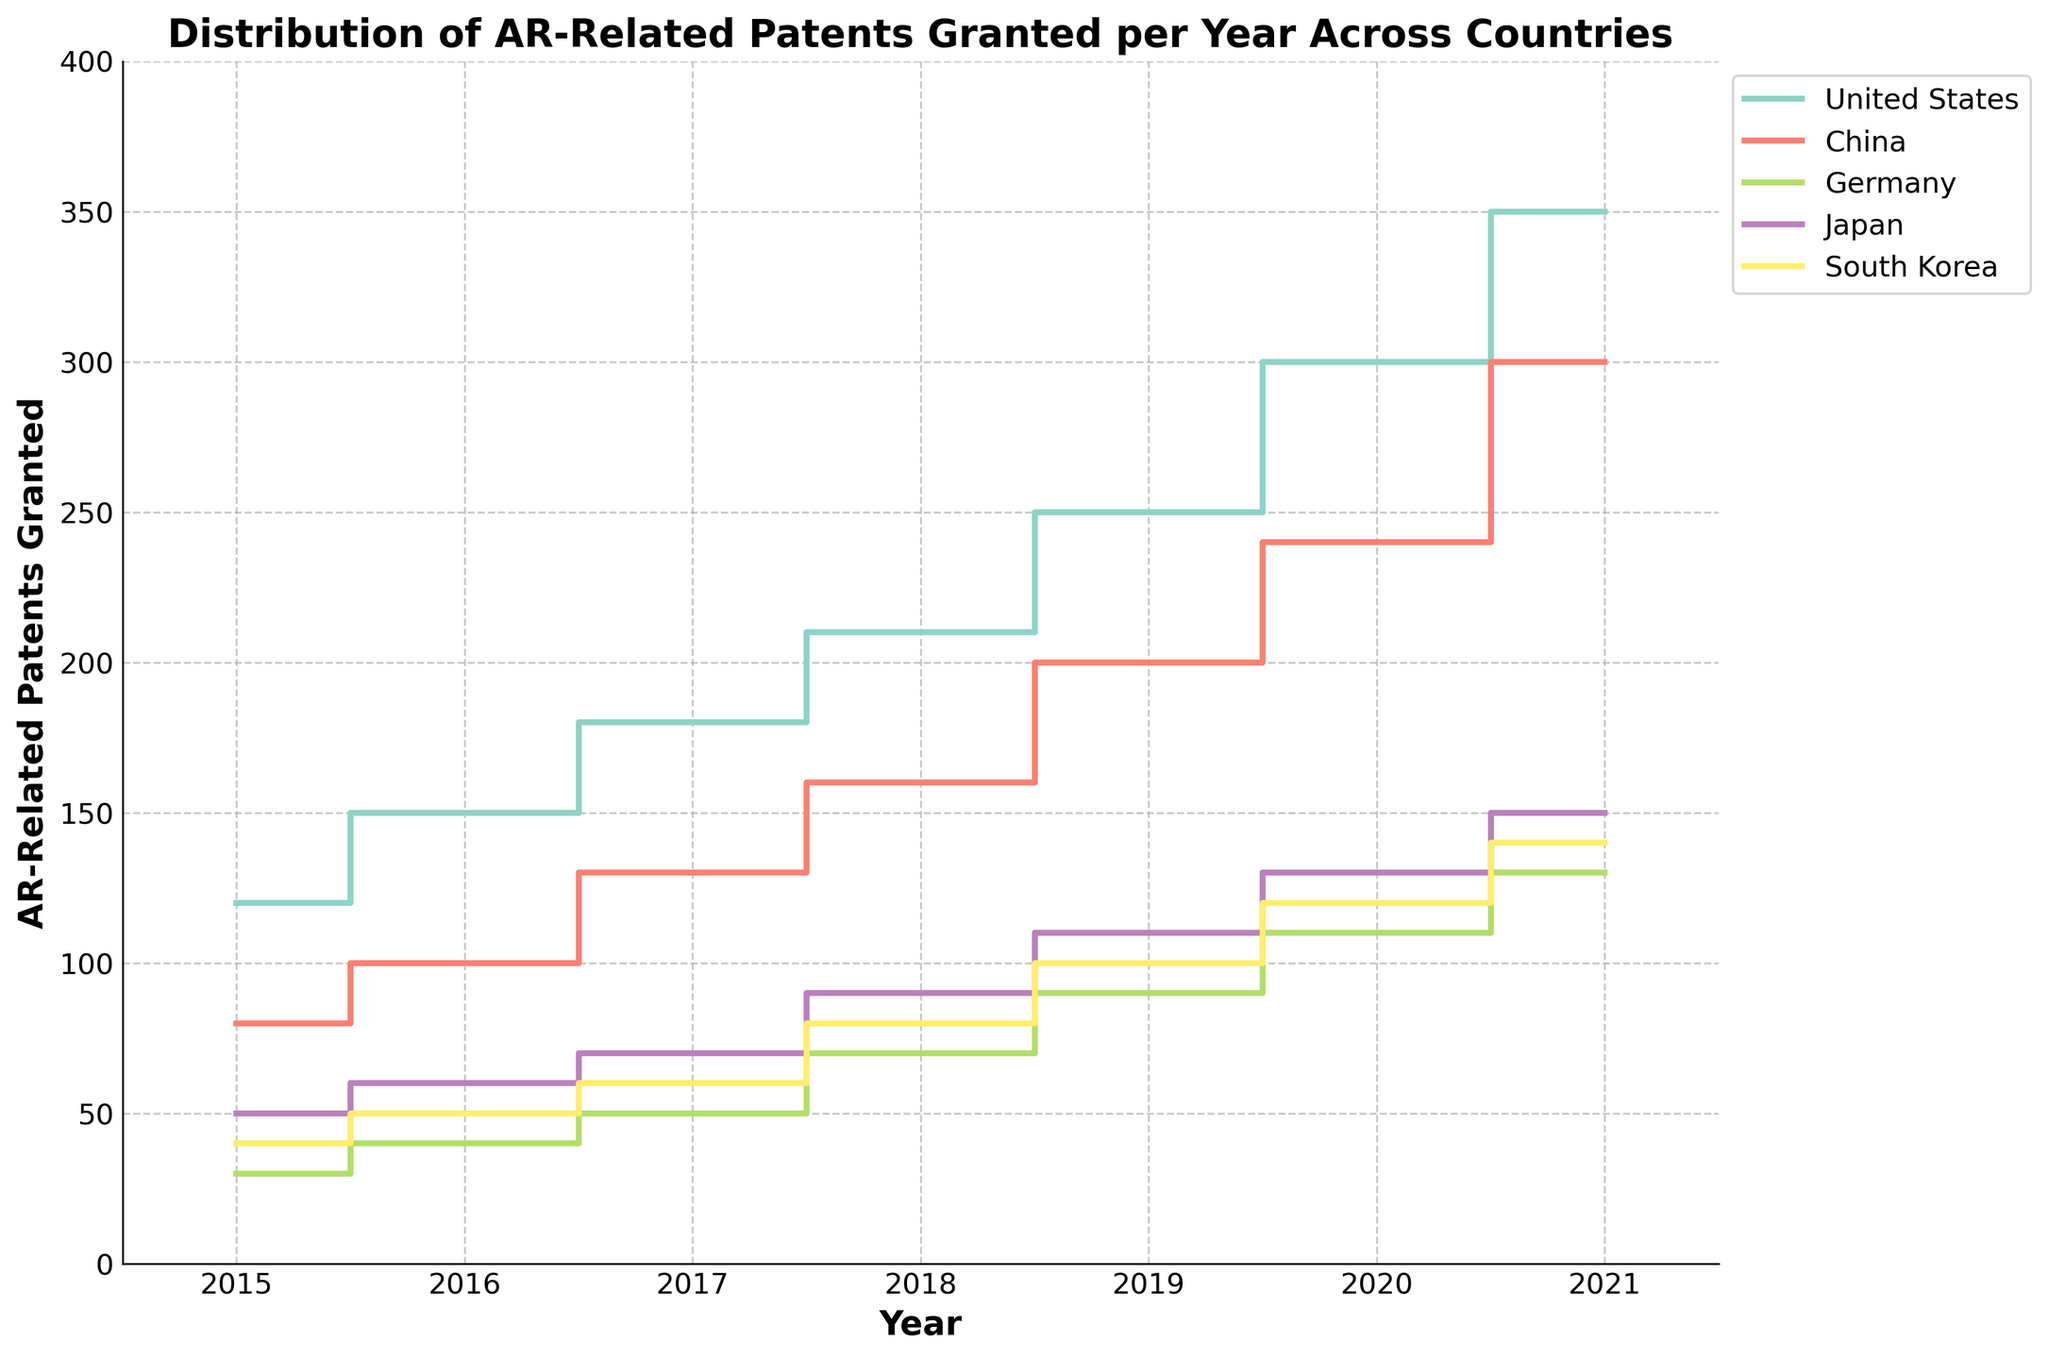What is the title of the plot? The title of the plot is usually displayed at the top of the figure. It provides a brief description of what the plot represents.
Answer: Distribution of AR-Related Patents Granted per Year Across Countries Which country has the highest number of AR-related patents granted in 2020? To determine this, find the year 2020 on the x-axis and locate the steps for all countries. Identify the highest value on the y-axis for that year.
Answer: United States How many AR-related patents were granted to Germany in 2018? Locate the line corresponding to Germany and find the value at the 2018 mark on the x-axis. The corresponding y-axis value gives the number of patents.
Answer: 70 Between which years did China see the largest increase in AR-related patents granted? Identify the step increments for China. Compare the differences between adjacent years to determine the largest increase.
Answer: 2020 to 2021 Which two countries had the same number of AR-related patents granted in 2015? Check the number of patents for each country at the 2015 mark on the x-axis and compare the values.
Answer: Japan and South Korea By how much did the number of AR-related patents granted in the United States increase from 2015 to 2021? Find the values for the United States in 2015 and 2021. Calculate the difference between these two values.
Answer: 230 What is the average number of AR-related patents granted per year in Japan from 2015 to 2021? Sum the number of patents granted in Japan from 2015 to 2021 and divide by the number of years (7).
Answer: (50+60+70+90+110+130+150)/7 = 94.3 Between which two consecutive years did South Korea have the smallest increase in AR-related patents granted? Examine the steps for South Korea and compare the increments between each pair of consecutive years to find the smallest increase.
Answer: 2019 to 2020 Which country had the second-highest number of AR-related patents granted in 2019? Find the values for each country in 2019 and identify the second-highest number.
Answer: China Did Germany grant more AR-related patents in 2017 or South Korea in 2020? Compare the value for Germany in 2017 with the value for South Korea in 2020 based on their respective lines.
Answer: South Korea in 2020 